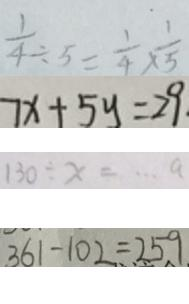<formula> <loc_0><loc_0><loc_500><loc_500>\frac { 1 } { 4 } \div 5 = \frac { 1 } { 4 } \times \frac { 1 } { 5 } 
 7 x + 5 y = 2 9 
 1 3 0 \div x = \cdots a 
 3 6 1 - 1 0 2 = 2 5 9</formula> 